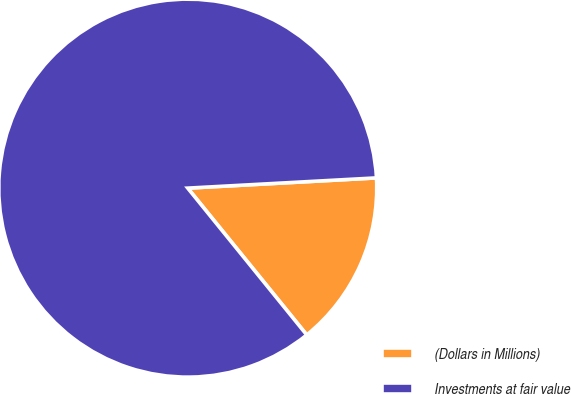Convert chart to OTSL. <chart><loc_0><loc_0><loc_500><loc_500><pie_chart><fcel>(Dollars in Millions)<fcel>Investments at fair value<nl><fcel>15.02%<fcel>84.98%<nl></chart> 